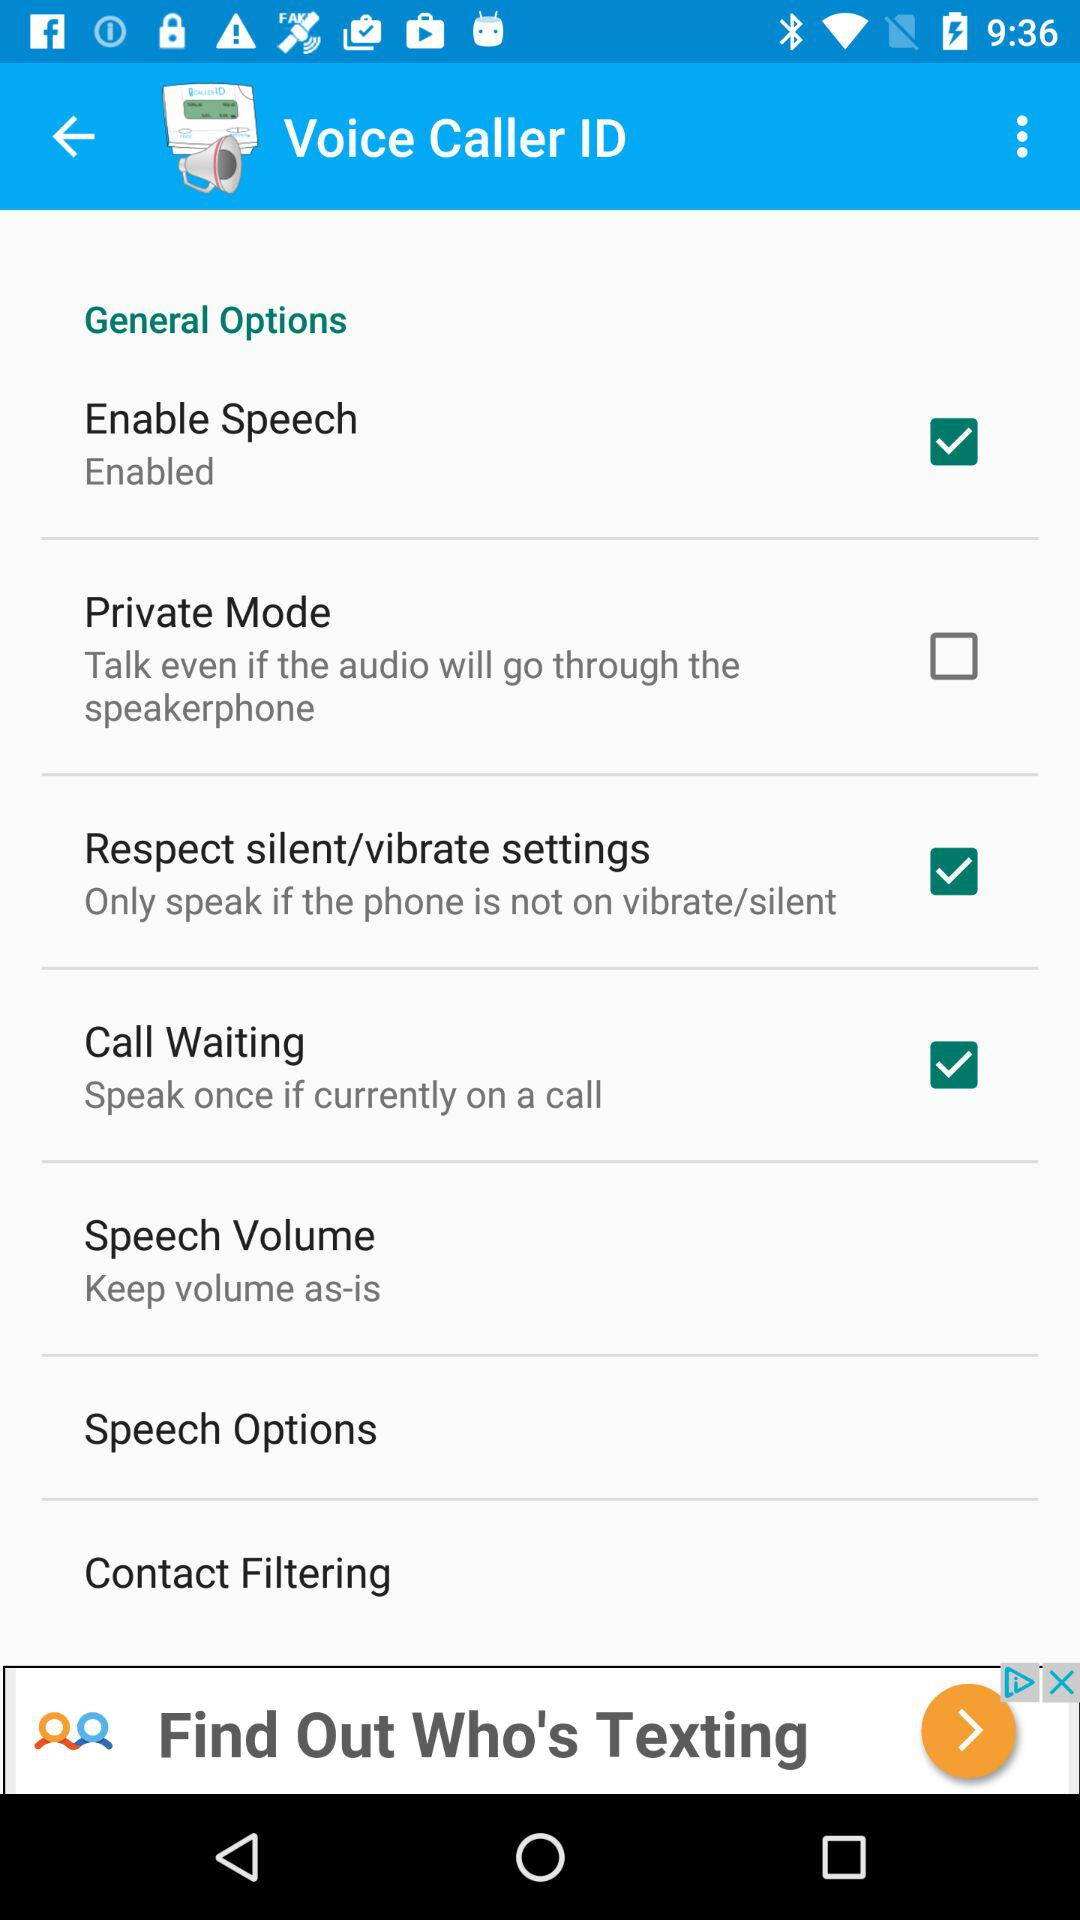Which option is marked as checked? The options marked as checked are "Enable Speech", "Respect silent/vibrate settings" and "Call Waiting". 